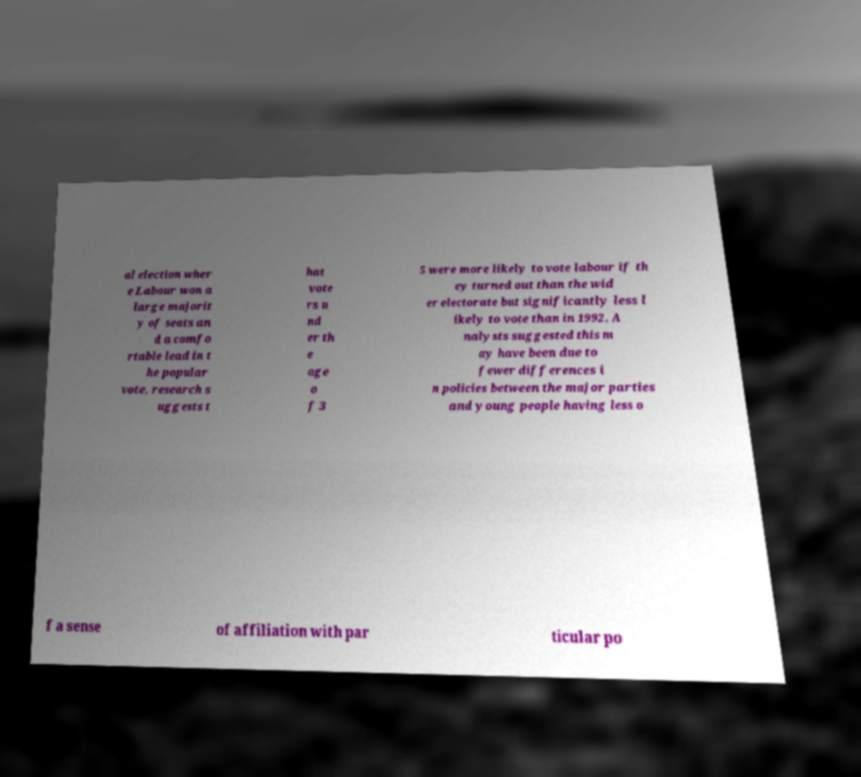For documentation purposes, I need the text within this image transcribed. Could you provide that? al election wher e Labour won a large majorit y of seats an d a comfo rtable lead in t he popular vote, research s uggests t hat vote rs u nd er th e age o f 3 5 were more likely to vote labour if th ey turned out than the wid er electorate but significantly less l ikely to vote than in 1992. A nalysts suggested this m ay have been due to fewer differences i n policies between the major parties and young people having less o f a sense of affiliation with par ticular po 